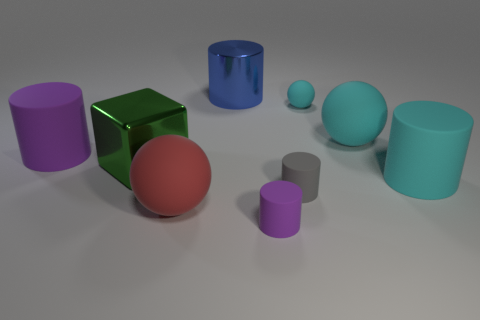What time of day do you think it is in this image, based on the lighting? The image is a rendered composition, and it's not depicting a real environment with natural light that would indicate a time of day. The lighting in the scene appears neutral and diffuse, suggesting it could be simulated studio lighting designed to reduce shadows and evenly illuminate the objects. 